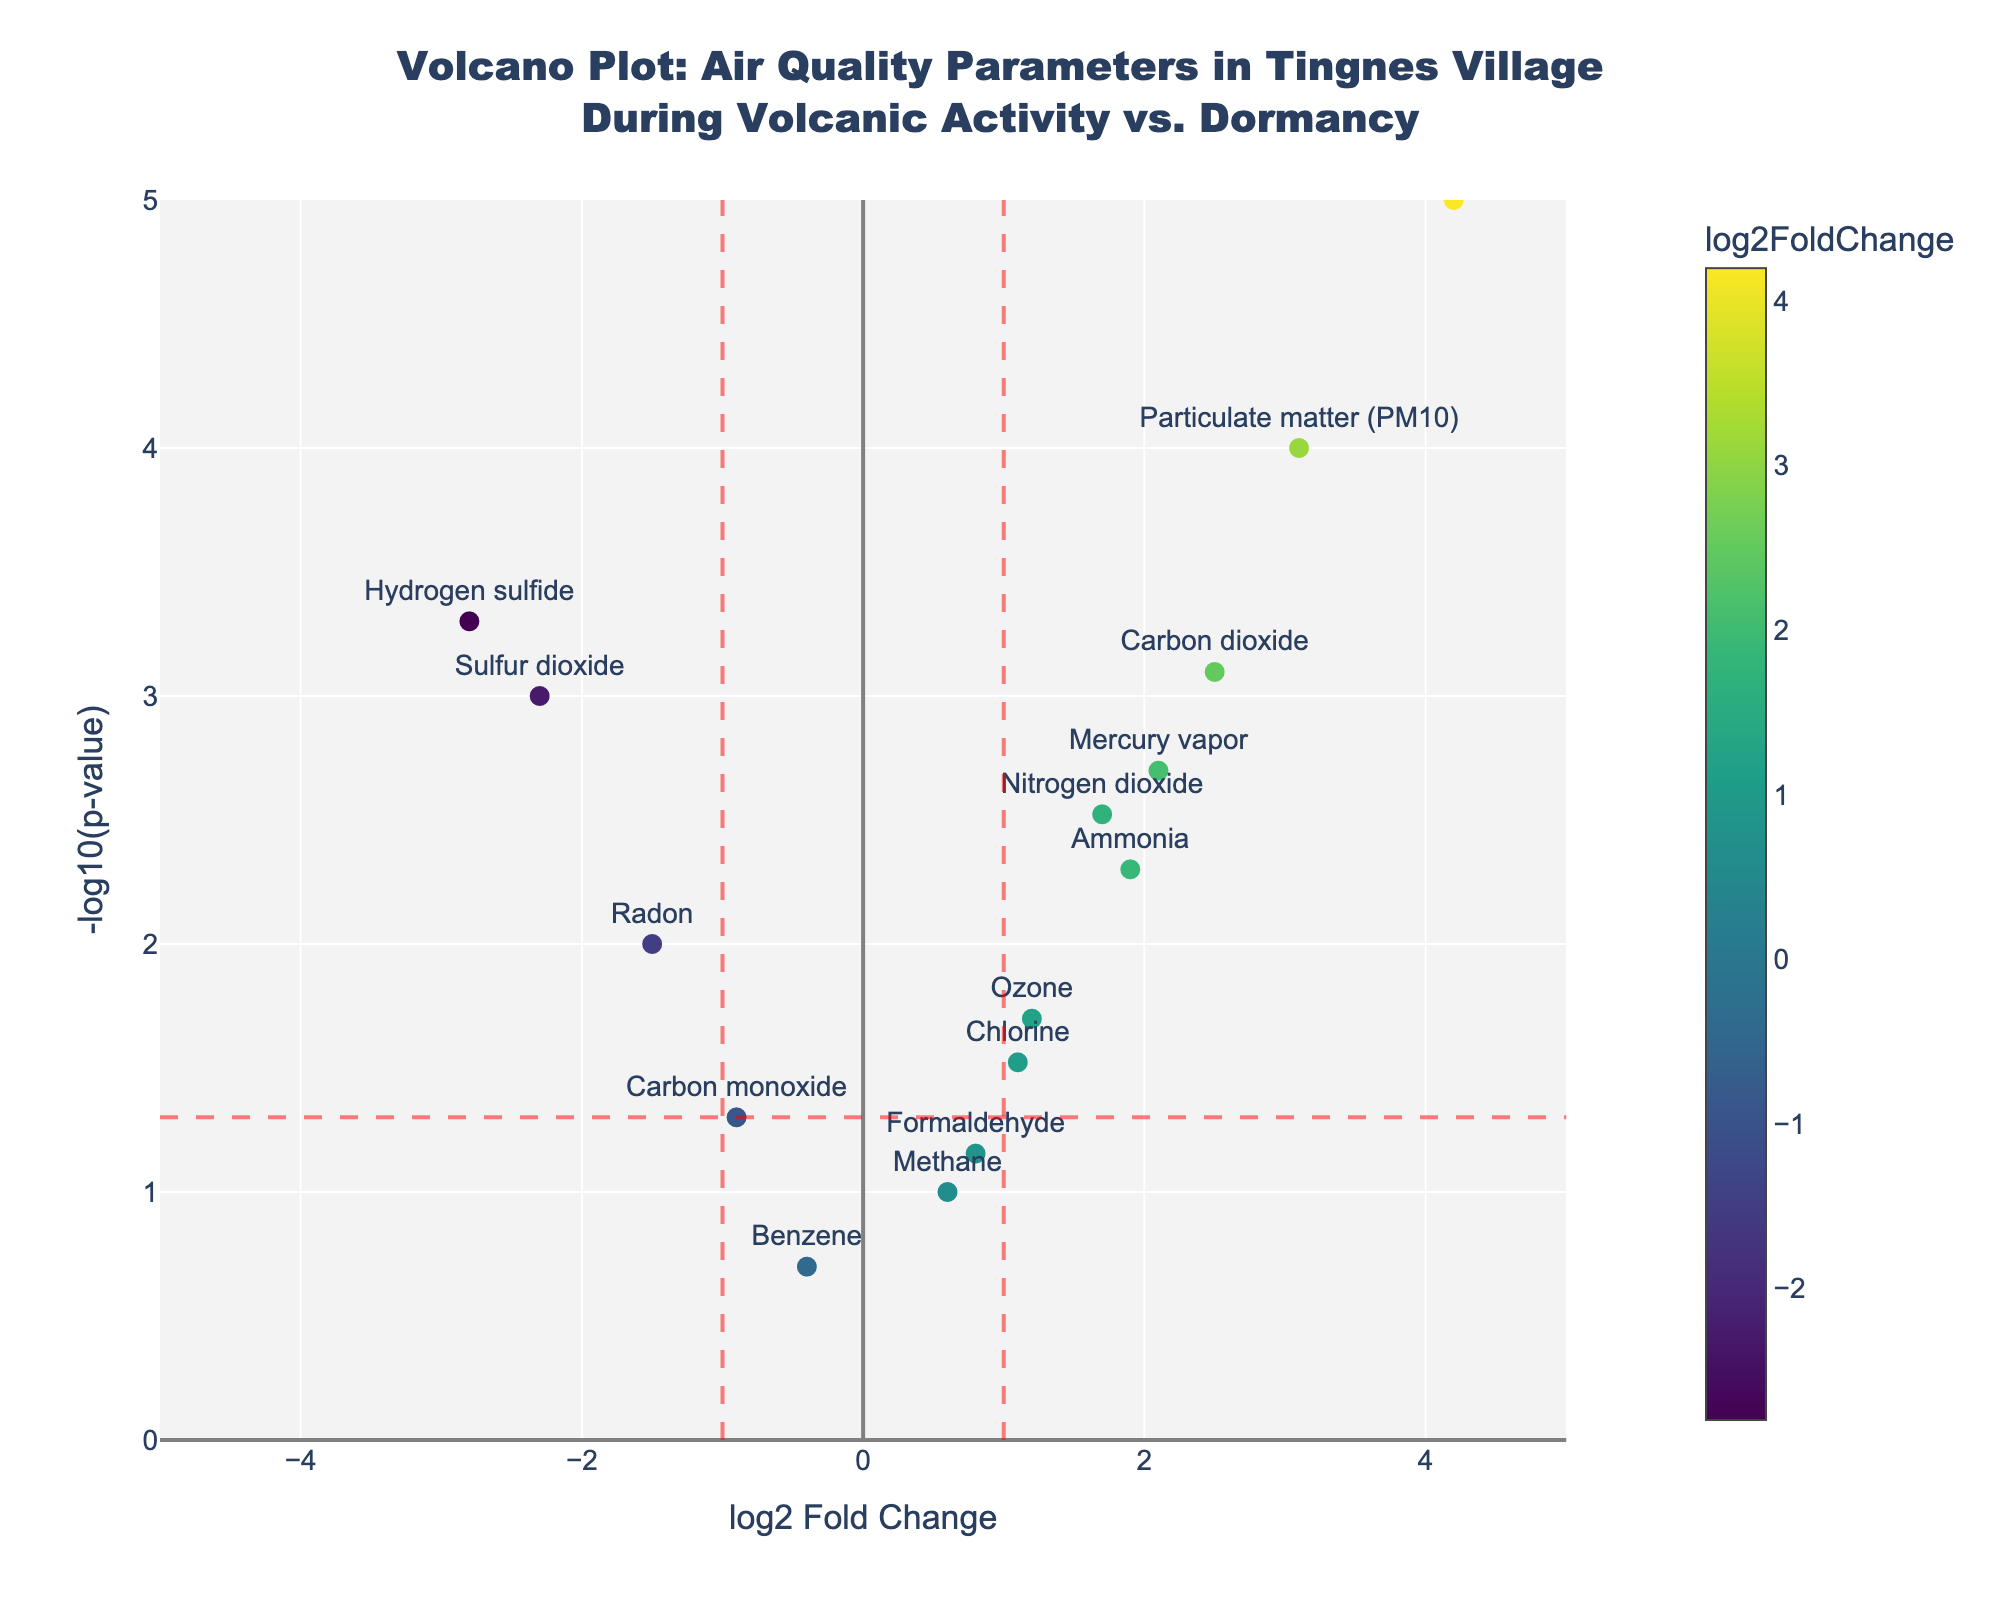What is the title of the figure? The title is located at the top of the figure. It reads "Volcano Plot: Air Quality Parameters in Tingnes Village During Volcanic Activity vs. Dormancy".
Answer: Volcano Plot: Air Quality Parameters in Tingnes Village During Volcanic Activity vs. Dormancy What's on the x-axis of the plot? The x-axis label can be read directly from the plot. It is labeled as "log2 Fold Change".
Answer: log2 Fold Change Which air quality parameter has the highest -log10(p-value)? By looking at the y-axis and finding the highest point on the plot, you can see that "Ash particles" has the highest -log10(p-value).
Answer: Ash particles How many data points have a log2 Fold Change greater than 1 and also are statistically significant (p-value < 0.05)? First, identify points with log2 Fold Change greater than 1 (right side of the vertical red line at x=1). Then, check these points for statistical significance by ensuring their -log10(p-value) is greater than -log10(0.05). Parameters that fit are "Nitrogen dioxide", "Mercury vapor", "Ammonia", "Carbon dioxide", and "Ash particles".
Answer: 5 Which air quality parameters show a decrease in concentration during volcanic activity compared to dormancy? Look at the points with negative log2 Fold Change (left of the zero line) and identify them. They are "Sulfur dioxide", "Carbon monoxide", "Hydrogen sulfide", "Radon", and "Benzene".
Answer: Sulfur dioxide, Carbon monoxide, Hydrogen sulfide, Radon, Benzene What is the log2 Fold Change for "Particulate matter (PM10)"? By checking the figure, locate "Particulate matter (PM10)" and read its log2 Fold Change from the x-axis.
Answer: 3.1 Which parameters fall outside the range of -1 to 1 log2 Fold Change but are not statistically significant (p-value ≥ 0.05)? Identify points outside the vertical dashed lines at -1 and 1, then check if -log10(p-value) is less than -log10(0.05). The parameter fitting this condition is "Methane".
Answer: Methane Which air quality parameter has the lowest log2 Fold Change? By reviewing the x-axis and comparing all points, "Hydrogen sulfide" has the lowest log2 Fold Change at -2.8.
Answer: Hydrogen sulfide How many total air quality parameters are included in this study? Count the total number of data points (markers) in the plot. This corresponds to the number of rows in the dataset.
Answer: 14 Which parameters increase in concentration during volcanic activity and are also statistically significant (p-value < 0.05)? Look at the points with positive log2 Fold Change (right of the zero line) and ensure they have -log10(p-value) greater than -log10(0.05). They are "Nitrogen dioxide", "Ozone", "Mercury vapor", "Ammonia", "Carbon dioxide", and "Ash particles".
Answer: Nitrogen dioxide, Ozone, Mercury vapor, Ammonia, Carbon dioxide, Ash particles 